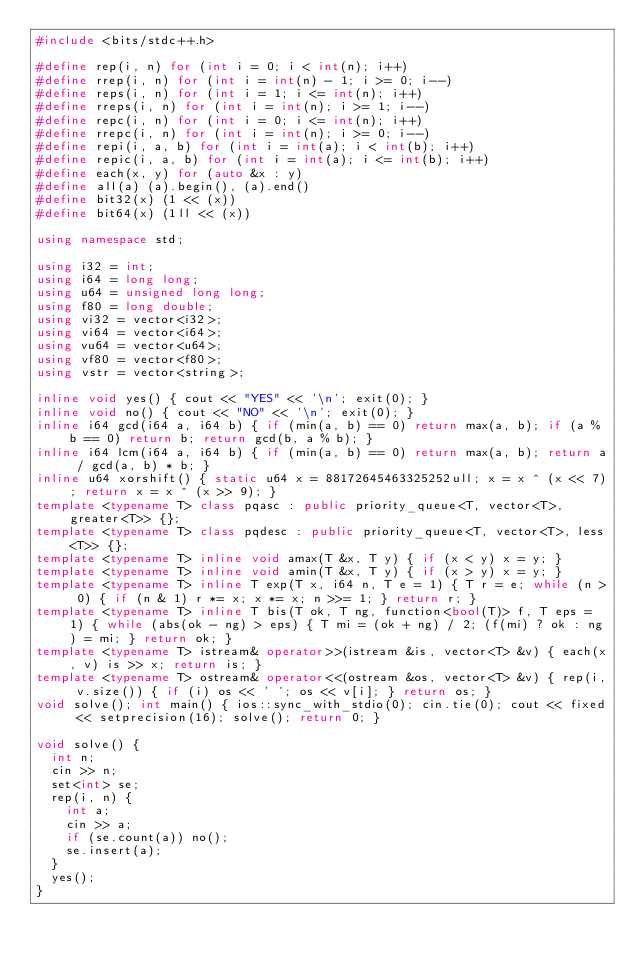<code> <loc_0><loc_0><loc_500><loc_500><_C++_>#include <bits/stdc++.h>

#define rep(i, n) for (int i = 0; i < int(n); i++)
#define rrep(i, n) for (int i = int(n) - 1; i >= 0; i--)
#define reps(i, n) for (int i = 1; i <= int(n); i++)
#define rreps(i, n) for (int i = int(n); i >= 1; i--)
#define repc(i, n) for (int i = 0; i <= int(n); i++)
#define rrepc(i, n) for (int i = int(n); i >= 0; i--)
#define repi(i, a, b) for (int i = int(a); i < int(b); i++)
#define repic(i, a, b) for (int i = int(a); i <= int(b); i++)
#define each(x, y) for (auto &x : y)
#define all(a) (a).begin(), (a).end()
#define bit32(x) (1 << (x))
#define bit64(x) (1ll << (x))

using namespace std;

using i32 = int;
using i64 = long long;
using u64 = unsigned long long;
using f80 = long double;
using vi32 = vector<i32>;
using vi64 = vector<i64>;
using vu64 = vector<u64>;
using vf80 = vector<f80>;
using vstr = vector<string>;

inline void yes() { cout << "YES" << '\n'; exit(0); }
inline void no() { cout << "NO" << '\n'; exit(0); }
inline i64 gcd(i64 a, i64 b) { if (min(a, b) == 0) return max(a, b); if (a % b == 0) return b; return gcd(b, a % b); }
inline i64 lcm(i64 a, i64 b) { if (min(a, b) == 0) return max(a, b); return a / gcd(a, b) * b; }
inline u64 xorshift() { static u64 x = 88172645463325252ull; x = x ^ (x << 7); return x = x ^ (x >> 9); }
template <typename T> class pqasc : public priority_queue<T, vector<T>, greater<T>> {};
template <typename T> class pqdesc : public priority_queue<T, vector<T>, less<T>> {};
template <typename T> inline void amax(T &x, T y) { if (x < y) x = y; }
template <typename T> inline void amin(T &x, T y) { if (x > y) x = y; }
template <typename T> inline T exp(T x, i64 n, T e = 1) { T r = e; while (n > 0) { if (n & 1) r *= x; x *= x; n >>= 1; } return r; }
template <typename T> inline T bis(T ok, T ng, function<bool(T)> f, T eps = 1) { while (abs(ok - ng) > eps) { T mi = (ok + ng) / 2; (f(mi) ? ok : ng) = mi; } return ok; }
template <typename T> istream& operator>>(istream &is, vector<T> &v) { each(x, v) is >> x; return is; }
template <typename T> ostream& operator<<(ostream &os, vector<T> &v) { rep(i, v.size()) { if (i) os << ' '; os << v[i]; } return os; }
void solve(); int main() { ios::sync_with_stdio(0); cin.tie(0); cout << fixed << setprecision(16); solve(); return 0; }

void solve() {
  int n;
  cin >> n;
  set<int> se;
  rep(i, n) {
    int a;
    cin >> a;
    if (se.count(a)) no();
    se.insert(a);
  }
  yes();
}
</code> 